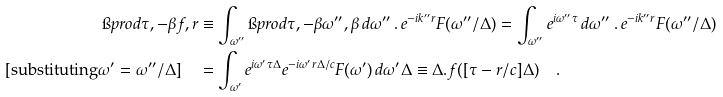<formula> <loc_0><loc_0><loc_500><loc_500>\i p r o d { \tau , - \beta } { f , r } & \equiv \int _ { \omega ^ { \prime \prime } } \i p r o d { \tau , - \beta } { \omega ^ { \prime \prime } , \beta } \, d \omega ^ { \prime \prime } \, . \, e ^ { - i k ^ { \prime \prime } r } F ( \omega ^ { \prime \prime } / \Delta ) = \int _ { \omega ^ { \prime \prime } } e ^ { i \omega ^ { \prime \prime } \tau } \, d \omega ^ { \prime \prime } \, . \, e ^ { - i k ^ { \prime \prime } r } F ( \omega ^ { \prime \prime } / \Delta ) \\ [ \text {substituting} \omega ^ { \prime } = \omega ^ { \prime \prime } / \Delta ] \quad & = \int _ { \omega ^ { \prime } } e ^ { i \omega ^ { \prime } \tau \Delta } e ^ { - i \omega ^ { \prime } r \Delta / c } F ( \omega ^ { \prime } ) \, d \omega ^ { \prime } \Delta \equiv \Delta . f ( [ \tau - r / c ] \Delta ) \quad .</formula> 